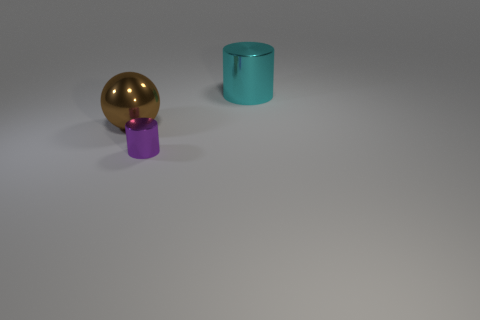Add 1 small blue cylinders. How many objects exist? 4 Subtract all cylinders. How many objects are left? 1 Add 1 big balls. How many big balls are left? 2 Add 3 metallic things. How many metallic things exist? 6 Subtract 0 gray blocks. How many objects are left? 3 Subtract all big objects. Subtract all tiny yellow matte spheres. How many objects are left? 1 